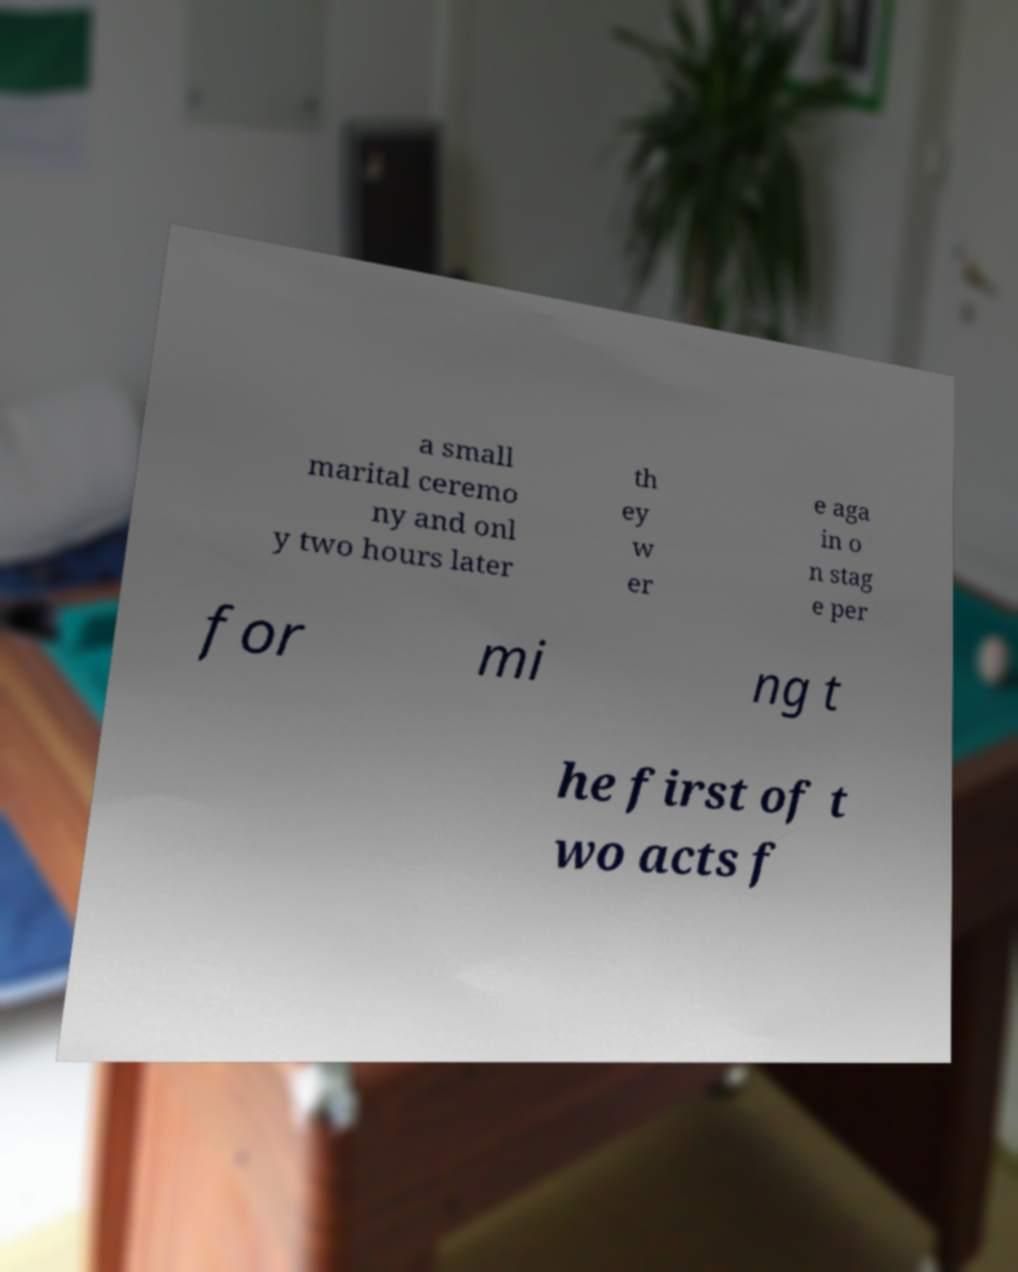Could you assist in decoding the text presented in this image and type it out clearly? a small marital ceremo ny and onl y two hours later th ey w er e aga in o n stag e per for mi ng t he first of t wo acts f 